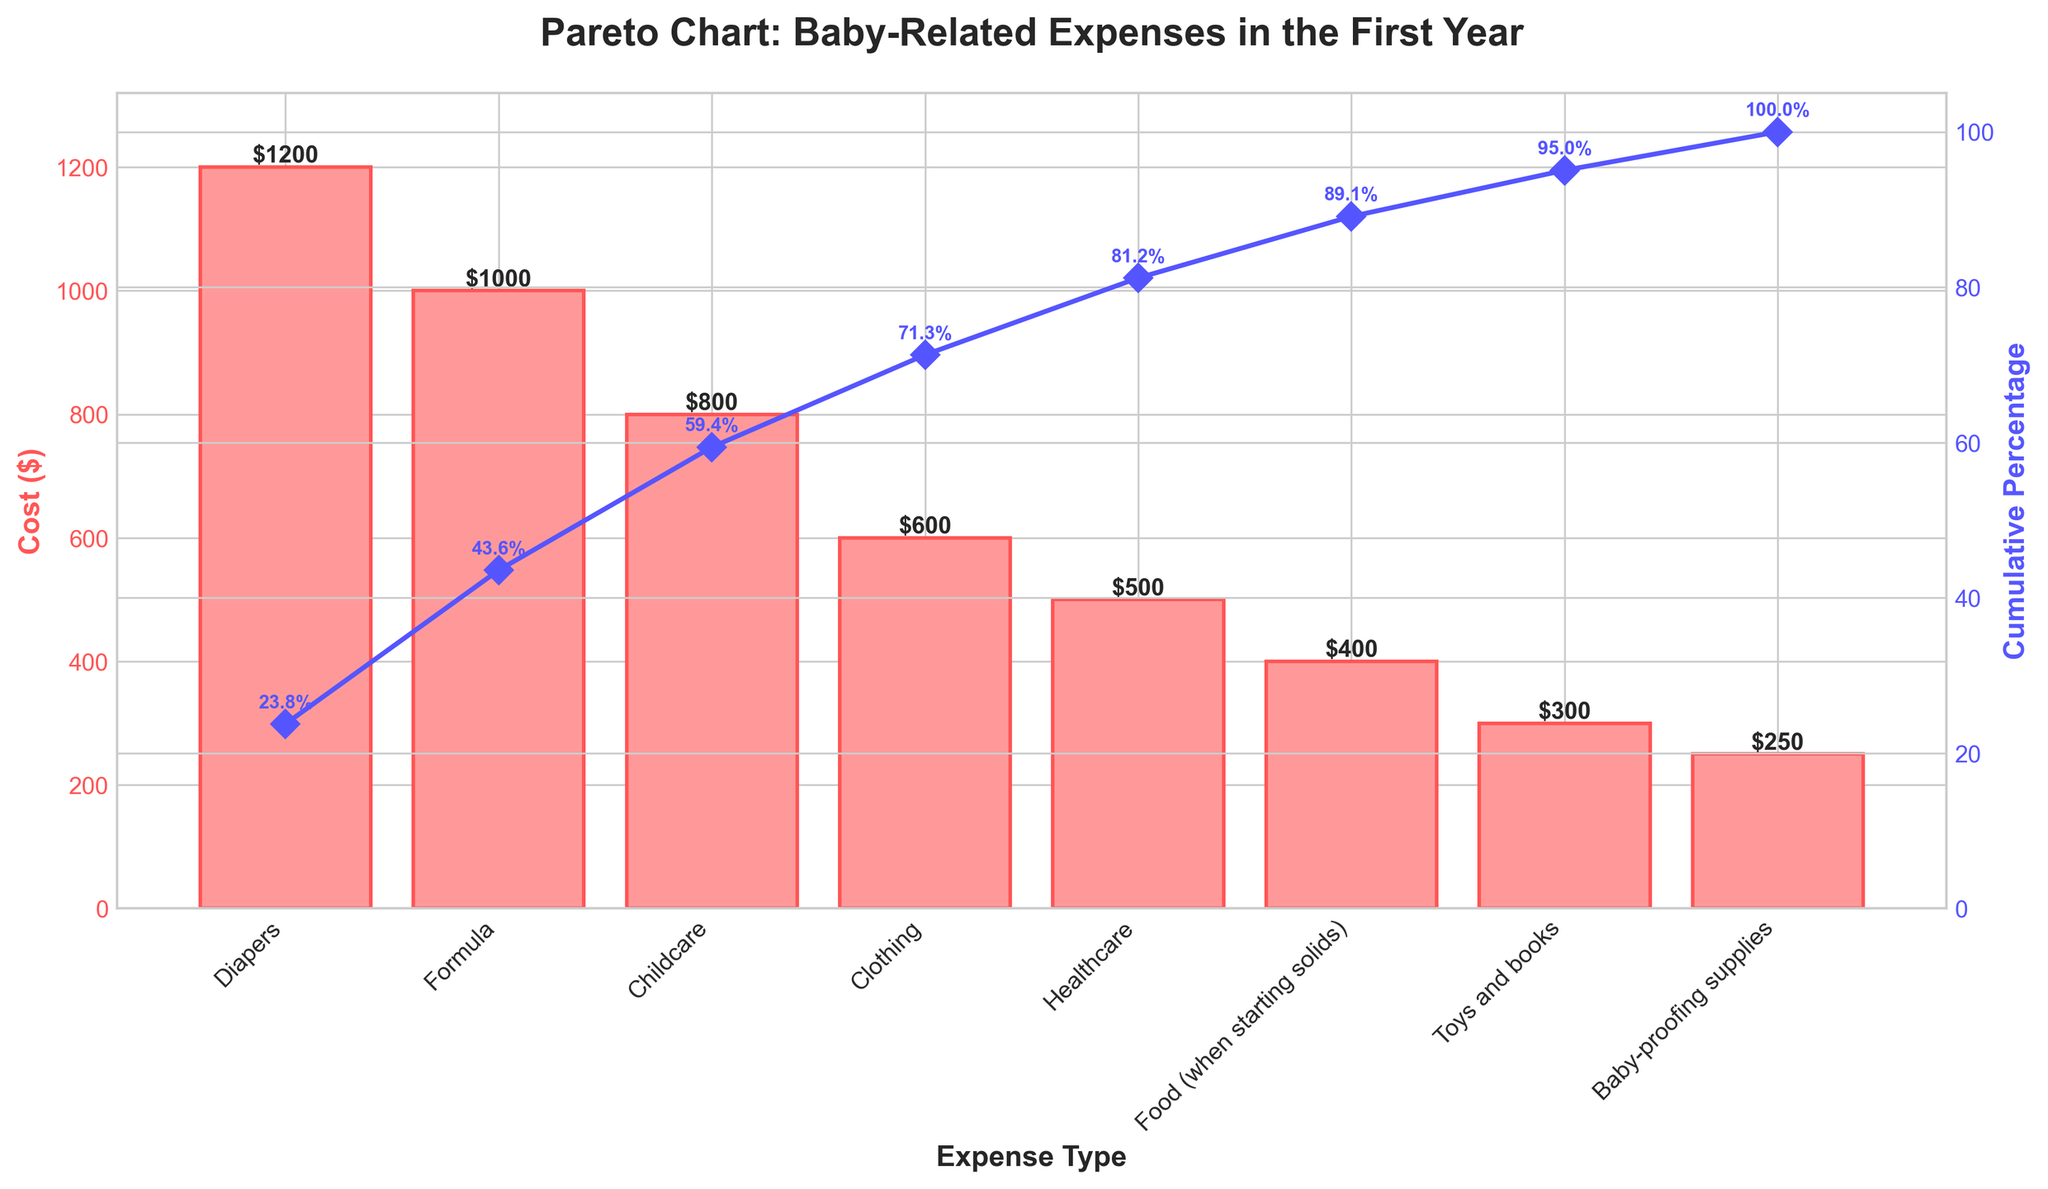What's the title of the chart? The title is usually located at the top of the chart. In this case, it reads "Pareto Chart: Baby-Related Expenses in the First Year".
Answer: Pareto Chart: Baby-Related Expenses in the First Year Which expense has the highest cost? The highest bar on the chart represents the expense with the highest cost. The expense labeled "Diapers" has the highest bar with a cost of $1200.
Answer: Diapers What's the cumulative percentage of the top three expenses? Look at the cumulative percentage line and check the values for the top three expenses: Diapers, Formula, and Childcare. The percentages are approximately 30.8%, 56.4%, and 76.9% respectively, so the total is 76.9%.
Answer: 76.9% How much more does spending on Diapers compare to spending on Clothing? Observe the heights of the bars for Diapers ($1200) and Clothing ($600). Subtract the cost of Clothing from the cost of Diapers, which is $1200 - $600 = $600.
Answer: $600 What's the average cost of all listed baby-related expenses? Sum all the listed expenses: $1200 + $1000 + $800 + $600 + $500 + $400 + $300 + $250 = $5050. There are 8 expenses, so the average is $5050 / 8 = $631.25.
Answer: $631.25 Which expenses together make up about 50% of the total cost? Check the cumulative percentage line for the value closest to 50% and see the corresponding expenses. The cumulative percentage for Diapers and Formula combined is approximately 56.4%.
Answer: Diapers and Formula Of the expenses listed, which one costs the least and by how much? The shortest bar represents the least expensive item, which is Baby-proofing supplies, costing $250. To find the difference from the highest cost item (Diapers, $1200), subtract $250 from $1200, which is $950.
Answer: Baby-proofing supplies, by $950 What is the relationship between the bar height and the cumulative percentage line? The bar heights represent the individual costs, while the cumulative percentage line shows how each addition of expenses contributes to the total cost cumulatively up to 100%. As the bars get shorter, the cumulative line flattens.
Answer: Bar height shows individual cost; line shows cumulative percentage Between which two expenses does the cumulative percentage cross 80%? Look at the cumulative percentage line and identify where it crosses the 80% mark. This occurs between Childcare and Clothing, at around 76.9% and 89.4%, respectively.
Answer: Childcare and Clothing 